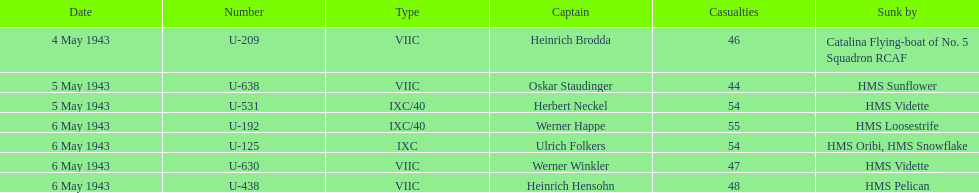What is the only vessel to sink multiple u-boats? HMS Vidette. 